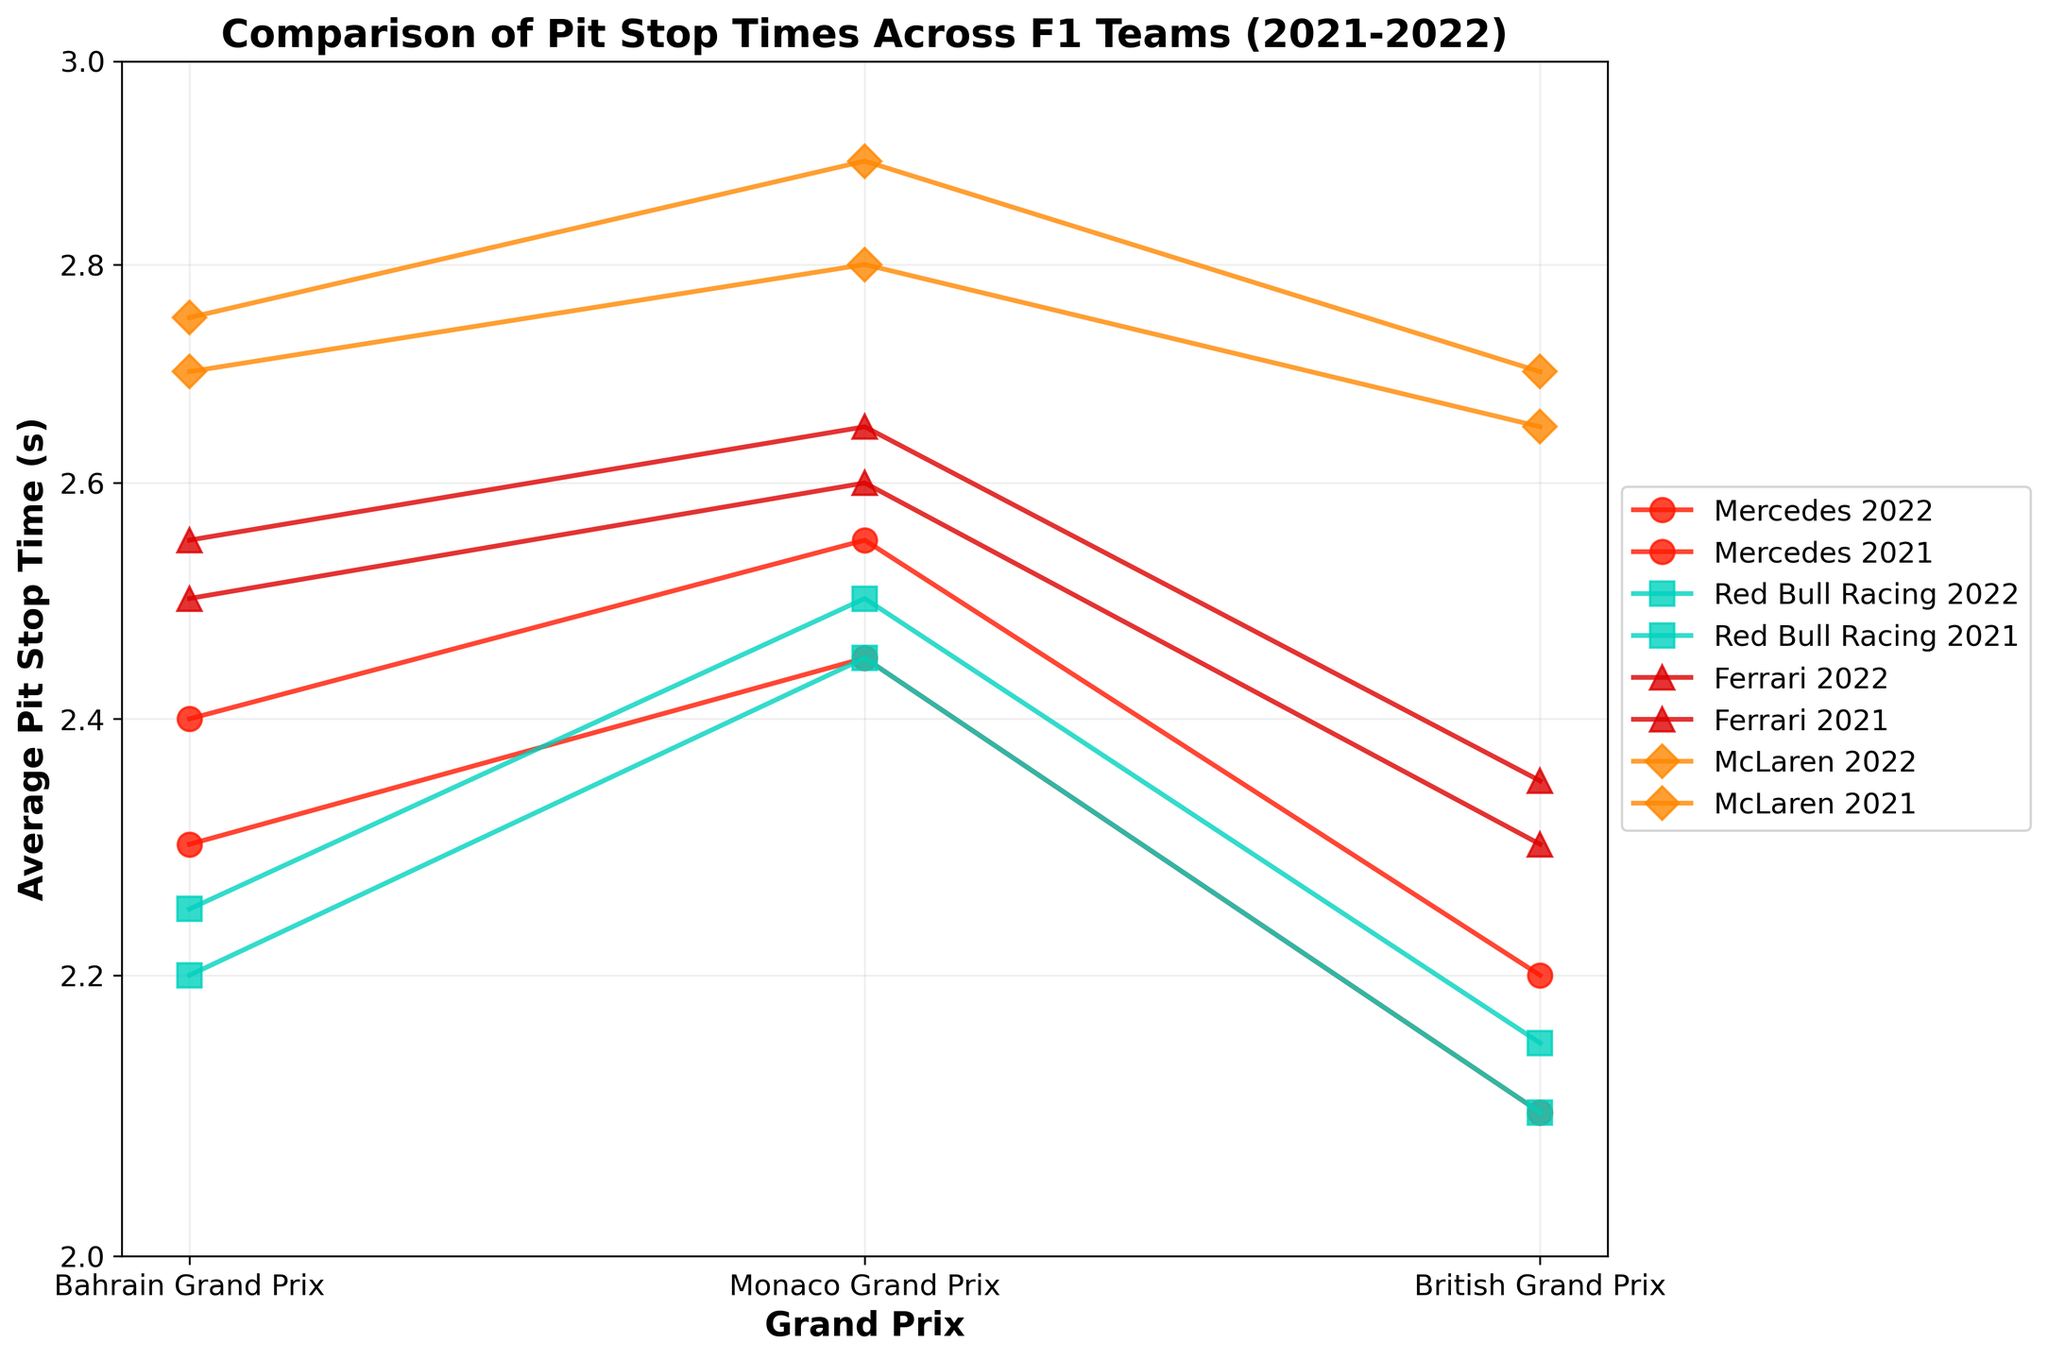What is the title of the figure? The title of the figure is displayed at the top and provides a summary of what the chart is about. In this case, the title is 'Comparison of Pit Stop Times Across F1 Teams (2021-2022)'.
Answer: Comparison of Pit Stop Times Across F1 Teams (2021-2022) Which team had the slowest average pit stop time in the 2022 Monaco Grand Prix? To find the slowest average pit stop time, look for the highest value on the y-axis for the 2022 Monaco Grand Prix. Ferrari had an average pit stop time of 2.60 seconds, which is the highest among all teams for that race.
Answer: Ferrari How does Mercedes' average pit stop time in the 2021 Bahrain Grand Prix compare to the 2022 Bahrain Grand Prix? Compare the values for Mercedes in the 2021 and 2022 Bahrain Grand Prix. In 2021, it was 2.40 seconds, and in 2022, it was 2.30 seconds. Mercedes improved their pit stop time by 0.10 seconds in 2022.
Answer: Mercedes improved by 0.10 seconds Which team's average pit stop time remained consistently the slowest across all races in both seasons? To determine which team consistently had the slowest times, observe the plot markers for each team across all race events and seasons. McLaren consistently appears higher on the y-axis than other teams.
Answer: McLaren What is the range of McLaren's average pit stop times in 2021? Look at the y-values for McLaren in the 2021 season. The times range from 2.70 seconds (British Grand Prix) to 2.90 seconds (Monaco Grand Prix). Subtracting the smallest value from the largest gives the range: 2.90 - 2.70 = 0.20 seconds.
Answer: 0.20 seconds In which season did Red Bull Racing have its best pit stop time for the British Grand Prix, and what was the time? Compare the pit stop times for Red Bull Racing for the British Grand Prix in both 2021 and 2022. The 2021 season had the best time at 2.10 seconds.
Answer: 2021, 2.10 seconds How much did Ferrari's average pit stop time change from 2021 to 2022 in the Bahrain Grand Prix? Check the y-values for Ferrari in the Bahrain Grand Prix for both years. In 2021 it was 2.55 seconds, and in 2022 it was 2.50 seconds. The change is 2.55 - 2.50 = 0.05 seconds.
Answer: Decreased by 0.05 seconds If we take the median average pit stop time for all teams in the 2021 Monaco Grand Prix, what is the value? Extract the pit stop times in the 2021 Monaco Grand Prix and find the median: 2.55 (Mercedes), 2.45 (Red Bull Racing), 2.65 (Ferrari), 2.90 (McLaren). Sorting these values: 2.45, 2.55, 2.65, 2.90. The median is the average of 2.55 and 2.65: (2.55 + 2.65) / 2 = 2.60.
Answer: 2.60 